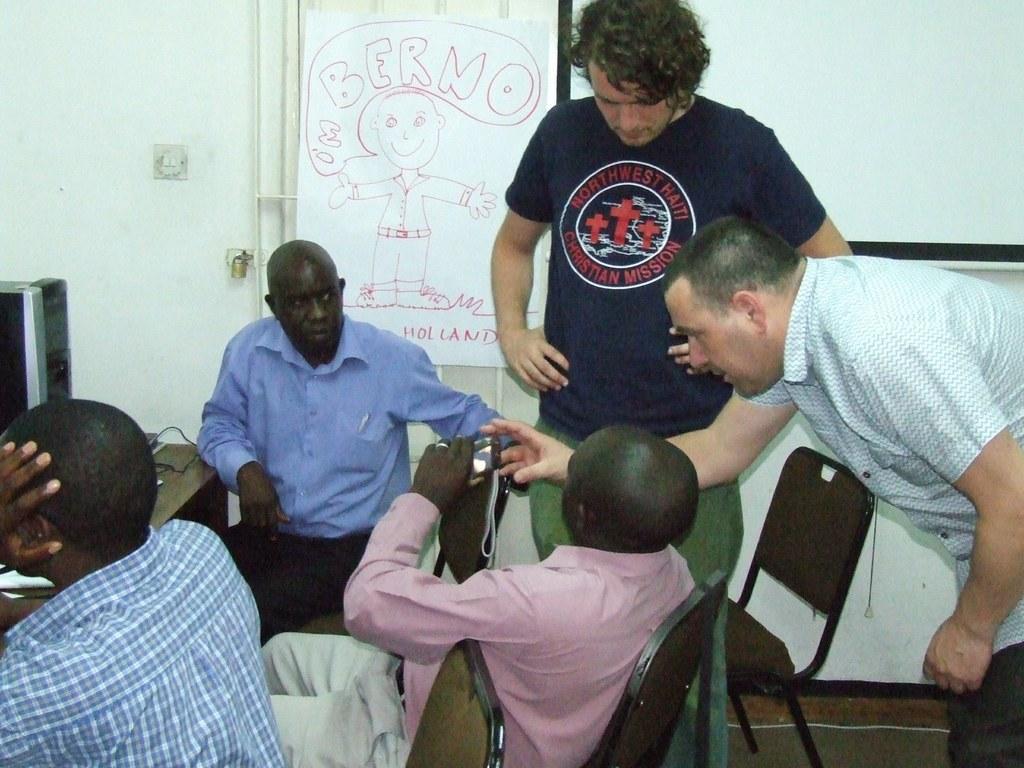Please provide a concise description of this image. In this image there are group of people sitting in chair , another 2 persons standing beside them ,and at the back ground there is table , desktop PC , door, a paper drawing, wall, switch, lock. 